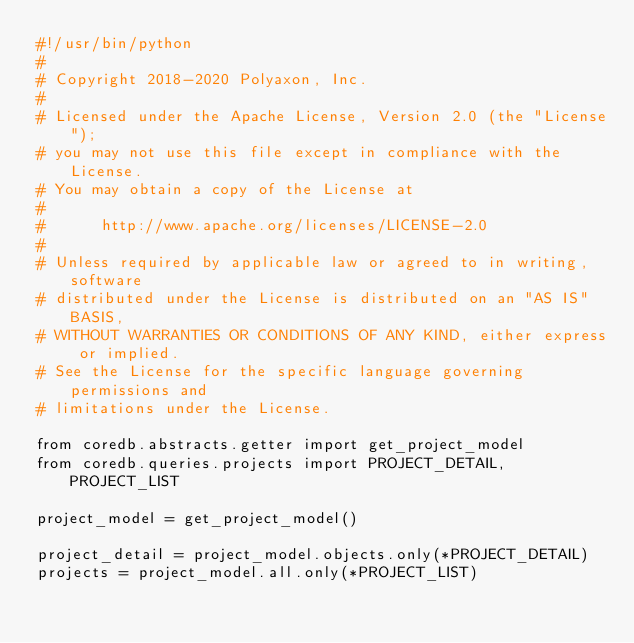Convert code to text. <code><loc_0><loc_0><loc_500><loc_500><_Python_>#!/usr/bin/python
#
# Copyright 2018-2020 Polyaxon, Inc.
#
# Licensed under the Apache License, Version 2.0 (the "License");
# you may not use this file except in compliance with the License.
# You may obtain a copy of the License at
#
#      http://www.apache.org/licenses/LICENSE-2.0
#
# Unless required by applicable law or agreed to in writing, software
# distributed under the License is distributed on an "AS IS" BASIS,
# WITHOUT WARRANTIES OR CONDITIONS OF ANY KIND, either express or implied.
# See the License for the specific language governing permissions and
# limitations under the License.

from coredb.abstracts.getter import get_project_model
from coredb.queries.projects import PROJECT_DETAIL, PROJECT_LIST

project_model = get_project_model()

project_detail = project_model.objects.only(*PROJECT_DETAIL)
projects = project_model.all.only(*PROJECT_LIST)
</code> 